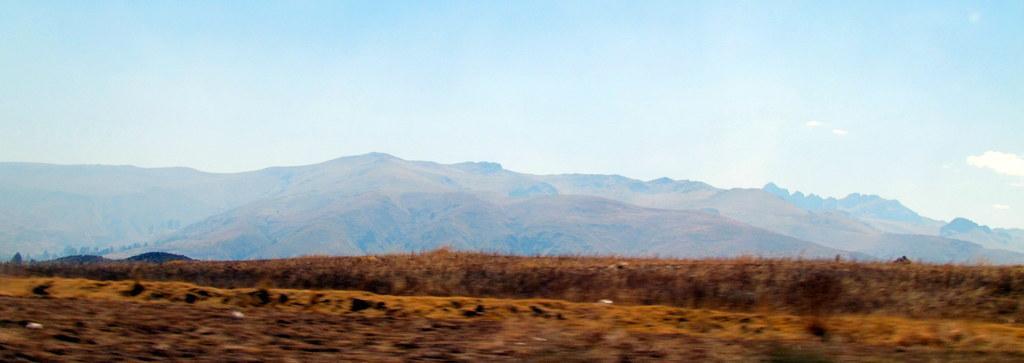Please provide a concise description of this image. There is a field and a grassy land present at the bottom of this image. We can see mountains in the middle of this image and the sky is in the background. 